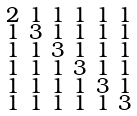<formula> <loc_0><loc_0><loc_500><loc_500>\begin{smallmatrix} 2 & 1 & 1 & 1 & 1 & 1 \\ 1 & 3 & 1 & 1 & 1 & 1 \\ 1 & 1 & 3 & 1 & 1 & 1 \\ 1 & 1 & 1 & 3 & 1 & 1 \\ 1 & 1 & 1 & 1 & 3 & 1 \\ 1 & 1 & 1 & 1 & 1 & 3 \end{smallmatrix}</formula> 